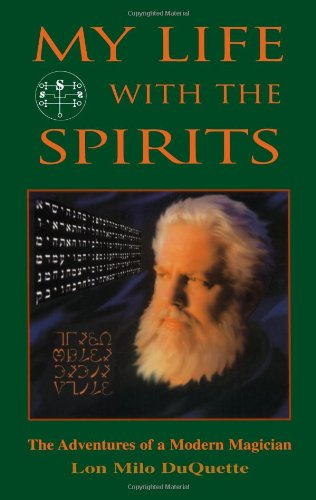What might be the significance of the author's expression and setting in this portrait? The author's thoughtful and intense expression, along with the mystical backdrop, is designed to convey a sense of deep contemplation and connection with the spiritual and magical realms he discusses in the book. 